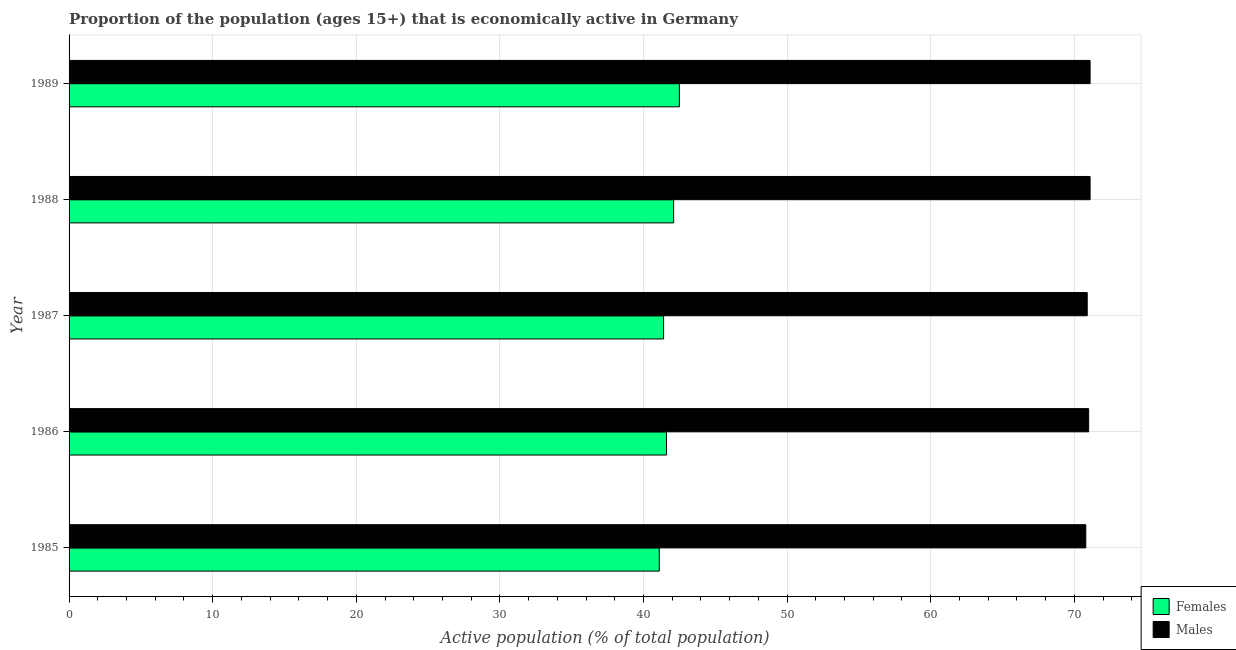How many groups of bars are there?
Ensure brevity in your answer.  5. What is the label of the 4th group of bars from the top?
Provide a short and direct response. 1986. What is the percentage of economically active female population in 1986?
Your answer should be very brief. 41.6. Across all years, what is the maximum percentage of economically active female population?
Provide a short and direct response. 42.5. Across all years, what is the minimum percentage of economically active male population?
Provide a short and direct response. 70.8. In which year was the percentage of economically active male population minimum?
Offer a terse response. 1985. What is the total percentage of economically active female population in the graph?
Your answer should be very brief. 208.7. What is the difference between the percentage of economically active male population in 1985 and the percentage of economically active female population in 1987?
Offer a terse response. 29.4. What is the average percentage of economically active female population per year?
Your answer should be compact. 41.74. In the year 1989, what is the difference between the percentage of economically active male population and percentage of economically active female population?
Offer a terse response. 28.6. What is the ratio of the percentage of economically active female population in 1985 to that in 1988?
Offer a very short reply. 0.98. Is the percentage of economically active male population in 1988 less than that in 1989?
Your answer should be compact. No. What is the difference between the highest and the second highest percentage of economically active male population?
Your answer should be compact. 0. What does the 2nd bar from the top in 1989 represents?
Your response must be concise. Females. What does the 1st bar from the bottom in 1986 represents?
Your answer should be compact. Females. How many bars are there?
Keep it short and to the point. 10. How many years are there in the graph?
Your answer should be compact. 5. Does the graph contain any zero values?
Provide a succinct answer. No. Does the graph contain grids?
Ensure brevity in your answer.  Yes. How many legend labels are there?
Provide a succinct answer. 2. What is the title of the graph?
Your answer should be compact. Proportion of the population (ages 15+) that is economically active in Germany. What is the label or title of the X-axis?
Keep it short and to the point. Active population (% of total population). What is the Active population (% of total population) in Females in 1985?
Provide a short and direct response. 41.1. What is the Active population (% of total population) of Males in 1985?
Provide a succinct answer. 70.8. What is the Active population (% of total population) in Females in 1986?
Your answer should be very brief. 41.6. What is the Active population (% of total population) of Males in 1986?
Provide a short and direct response. 71. What is the Active population (% of total population) of Females in 1987?
Keep it short and to the point. 41.4. What is the Active population (% of total population) of Males in 1987?
Offer a very short reply. 70.9. What is the Active population (% of total population) in Females in 1988?
Offer a terse response. 42.1. What is the Active population (% of total population) of Males in 1988?
Offer a terse response. 71.1. What is the Active population (% of total population) in Females in 1989?
Provide a succinct answer. 42.5. What is the Active population (% of total population) of Males in 1989?
Your answer should be very brief. 71.1. Across all years, what is the maximum Active population (% of total population) of Females?
Keep it short and to the point. 42.5. Across all years, what is the maximum Active population (% of total population) in Males?
Provide a succinct answer. 71.1. Across all years, what is the minimum Active population (% of total population) of Females?
Your answer should be very brief. 41.1. Across all years, what is the minimum Active population (% of total population) in Males?
Give a very brief answer. 70.8. What is the total Active population (% of total population) in Females in the graph?
Offer a very short reply. 208.7. What is the total Active population (% of total population) of Males in the graph?
Ensure brevity in your answer.  354.9. What is the difference between the Active population (% of total population) of Males in 1985 and that in 1986?
Provide a short and direct response. -0.2. What is the difference between the Active population (% of total population) of Females in 1985 and that in 1987?
Keep it short and to the point. -0.3. What is the difference between the Active population (% of total population) in Males in 1985 and that in 1988?
Provide a succinct answer. -0.3. What is the difference between the Active population (% of total population) of Males in 1985 and that in 1989?
Ensure brevity in your answer.  -0.3. What is the difference between the Active population (% of total population) of Males in 1986 and that in 1987?
Offer a very short reply. 0.1. What is the difference between the Active population (% of total population) of Males in 1986 and that in 1988?
Provide a succinct answer. -0.1. What is the difference between the Active population (% of total population) in Females in 1986 and that in 1989?
Provide a succinct answer. -0.9. What is the difference between the Active population (% of total population) of Males in 1986 and that in 1989?
Give a very brief answer. -0.1. What is the difference between the Active population (% of total population) in Males in 1987 and that in 1989?
Provide a succinct answer. -0.2. What is the difference between the Active population (% of total population) of Females in 1988 and that in 1989?
Provide a short and direct response. -0.4. What is the difference between the Active population (% of total population) of Males in 1988 and that in 1989?
Provide a short and direct response. 0. What is the difference between the Active population (% of total population) of Females in 1985 and the Active population (% of total population) of Males in 1986?
Provide a short and direct response. -29.9. What is the difference between the Active population (% of total population) of Females in 1985 and the Active population (% of total population) of Males in 1987?
Your response must be concise. -29.8. What is the difference between the Active population (% of total population) of Females in 1985 and the Active population (% of total population) of Males in 1989?
Provide a short and direct response. -30. What is the difference between the Active population (% of total population) of Females in 1986 and the Active population (% of total population) of Males in 1987?
Your answer should be compact. -29.3. What is the difference between the Active population (% of total population) of Females in 1986 and the Active population (% of total population) of Males in 1988?
Offer a very short reply. -29.5. What is the difference between the Active population (% of total population) of Females in 1986 and the Active population (% of total population) of Males in 1989?
Provide a short and direct response. -29.5. What is the difference between the Active population (% of total population) in Females in 1987 and the Active population (% of total population) in Males in 1988?
Give a very brief answer. -29.7. What is the difference between the Active population (% of total population) in Females in 1987 and the Active population (% of total population) in Males in 1989?
Your answer should be compact. -29.7. What is the average Active population (% of total population) in Females per year?
Make the answer very short. 41.74. What is the average Active population (% of total population) in Males per year?
Provide a short and direct response. 70.98. In the year 1985, what is the difference between the Active population (% of total population) in Females and Active population (% of total population) in Males?
Provide a succinct answer. -29.7. In the year 1986, what is the difference between the Active population (% of total population) in Females and Active population (% of total population) in Males?
Provide a succinct answer. -29.4. In the year 1987, what is the difference between the Active population (% of total population) in Females and Active population (% of total population) in Males?
Provide a succinct answer. -29.5. In the year 1988, what is the difference between the Active population (% of total population) of Females and Active population (% of total population) of Males?
Ensure brevity in your answer.  -29. In the year 1989, what is the difference between the Active population (% of total population) of Females and Active population (% of total population) of Males?
Make the answer very short. -28.6. What is the ratio of the Active population (% of total population) in Males in 1985 to that in 1986?
Make the answer very short. 1. What is the ratio of the Active population (% of total population) in Males in 1985 to that in 1987?
Your answer should be very brief. 1. What is the ratio of the Active population (% of total population) in Females in 1985 to that in 1988?
Your answer should be compact. 0.98. What is the ratio of the Active population (% of total population) of Males in 1985 to that in 1988?
Your answer should be very brief. 1. What is the ratio of the Active population (% of total population) of Females in 1985 to that in 1989?
Offer a very short reply. 0.97. What is the ratio of the Active population (% of total population) of Females in 1986 to that in 1987?
Provide a succinct answer. 1. What is the ratio of the Active population (% of total population) in Males in 1986 to that in 1987?
Your answer should be compact. 1. What is the ratio of the Active population (% of total population) of Females in 1986 to that in 1989?
Your response must be concise. 0.98. What is the ratio of the Active population (% of total population) in Males in 1986 to that in 1989?
Your answer should be very brief. 1. What is the ratio of the Active population (% of total population) of Females in 1987 to that in 1988?
Provide a succinct answer. 0.98. What is the ratio of the Active population (% of total population) in Males in 1987 to that in 1988?
Your response must be concise. 1. What is the ratio of the Active population (% of total population) in Females in 1987 to that in 1989?
Keep it short and to the point. 0.97. What is the ratio of the Active population (% of total population) of Males in 1987 to that in 1989?
Make the answer very short. 1. What is the ratio of the Active population (% of total population) of Females in 1988 to that in 1989?
Make the answer very short. 0.99. What is the difference between the highest and the second highest Active population (% of total population) of Females?
Offer a terse response. 0.4. What is the difference between the highest and the second highest Active population (% of total population) in Males?
Keep it short and to the point. 0. 